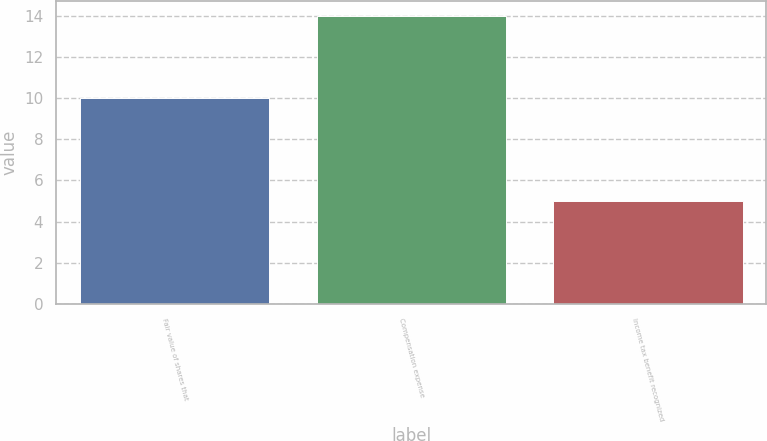<chart> <loc_0><loc_0><loc_500><loc_500><bar_chart><fcel>Fair value of shares that<fcel>Compensation expense<fcel>Income tax benefit recognized<nl><fcel>10<fcel>14<fcel>5<nl></chart> 